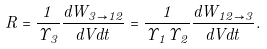Convert formula to latex. <formula><loc_0><loc_0><loc_500><loc_500>R = \frac { 1 } { \Upsilon _ { 3 } } \frac { d W _ { 3 \rightarrow 1 2 } } { d V d t } = \frac { 1 } { \Upsilon _ { 1 } \Upsilon _ { 2 } } \frac { d W _ { 1 2 \rightarrow 3 } } { d V d t } .</formula> 